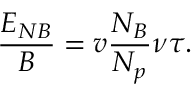Convert formula to latex. <formula><loc_0><loc_0><loc_500><loc_500>\frac { E _ { N B } } { B } = v \frac { N _ { B } } { N _ { p } } \nu \tau .</formula> 